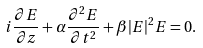Convert formula to latex. <formula><loc_0><loc_0><loc_500><loc_500>i \frac { \partial E } { \partial z } + \alpha \frac { \partial ^ { 2 } E } { \partial t ^ { 2 } } + \beta | E | ^ { 2 } E = 0 .</formula> 